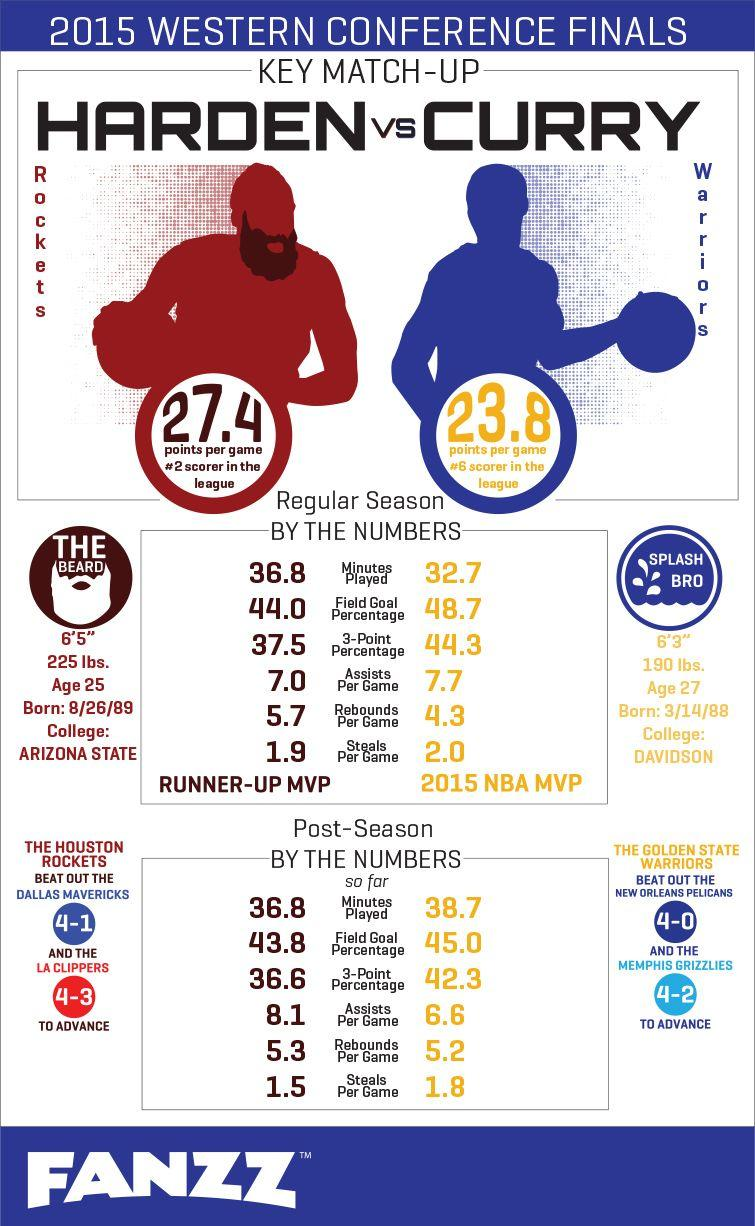Point out several critical features in this image. The Golden State Warriors have a 3-point shooting percentage of 42.3%. Splash Bro weighed 190 pounds. The person known as The Beard is 6 feet and 5 inches tall. The Golden State Warriors defeated the New Orleans Pelicans and the Memphis Grizzlies in a series of matches. The weight of The Beard was 225 pounds. 